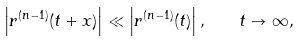Convert formula to latex. <formula><loc_0><loc_0><loc_500><loc_500>\left | r ^ { ( n - 1 ) } ( t + x ) \right | \ll \left | r ^ { ( n - 1 ) } ( t ) \right | , \quad t \to \infty ,</formula> 